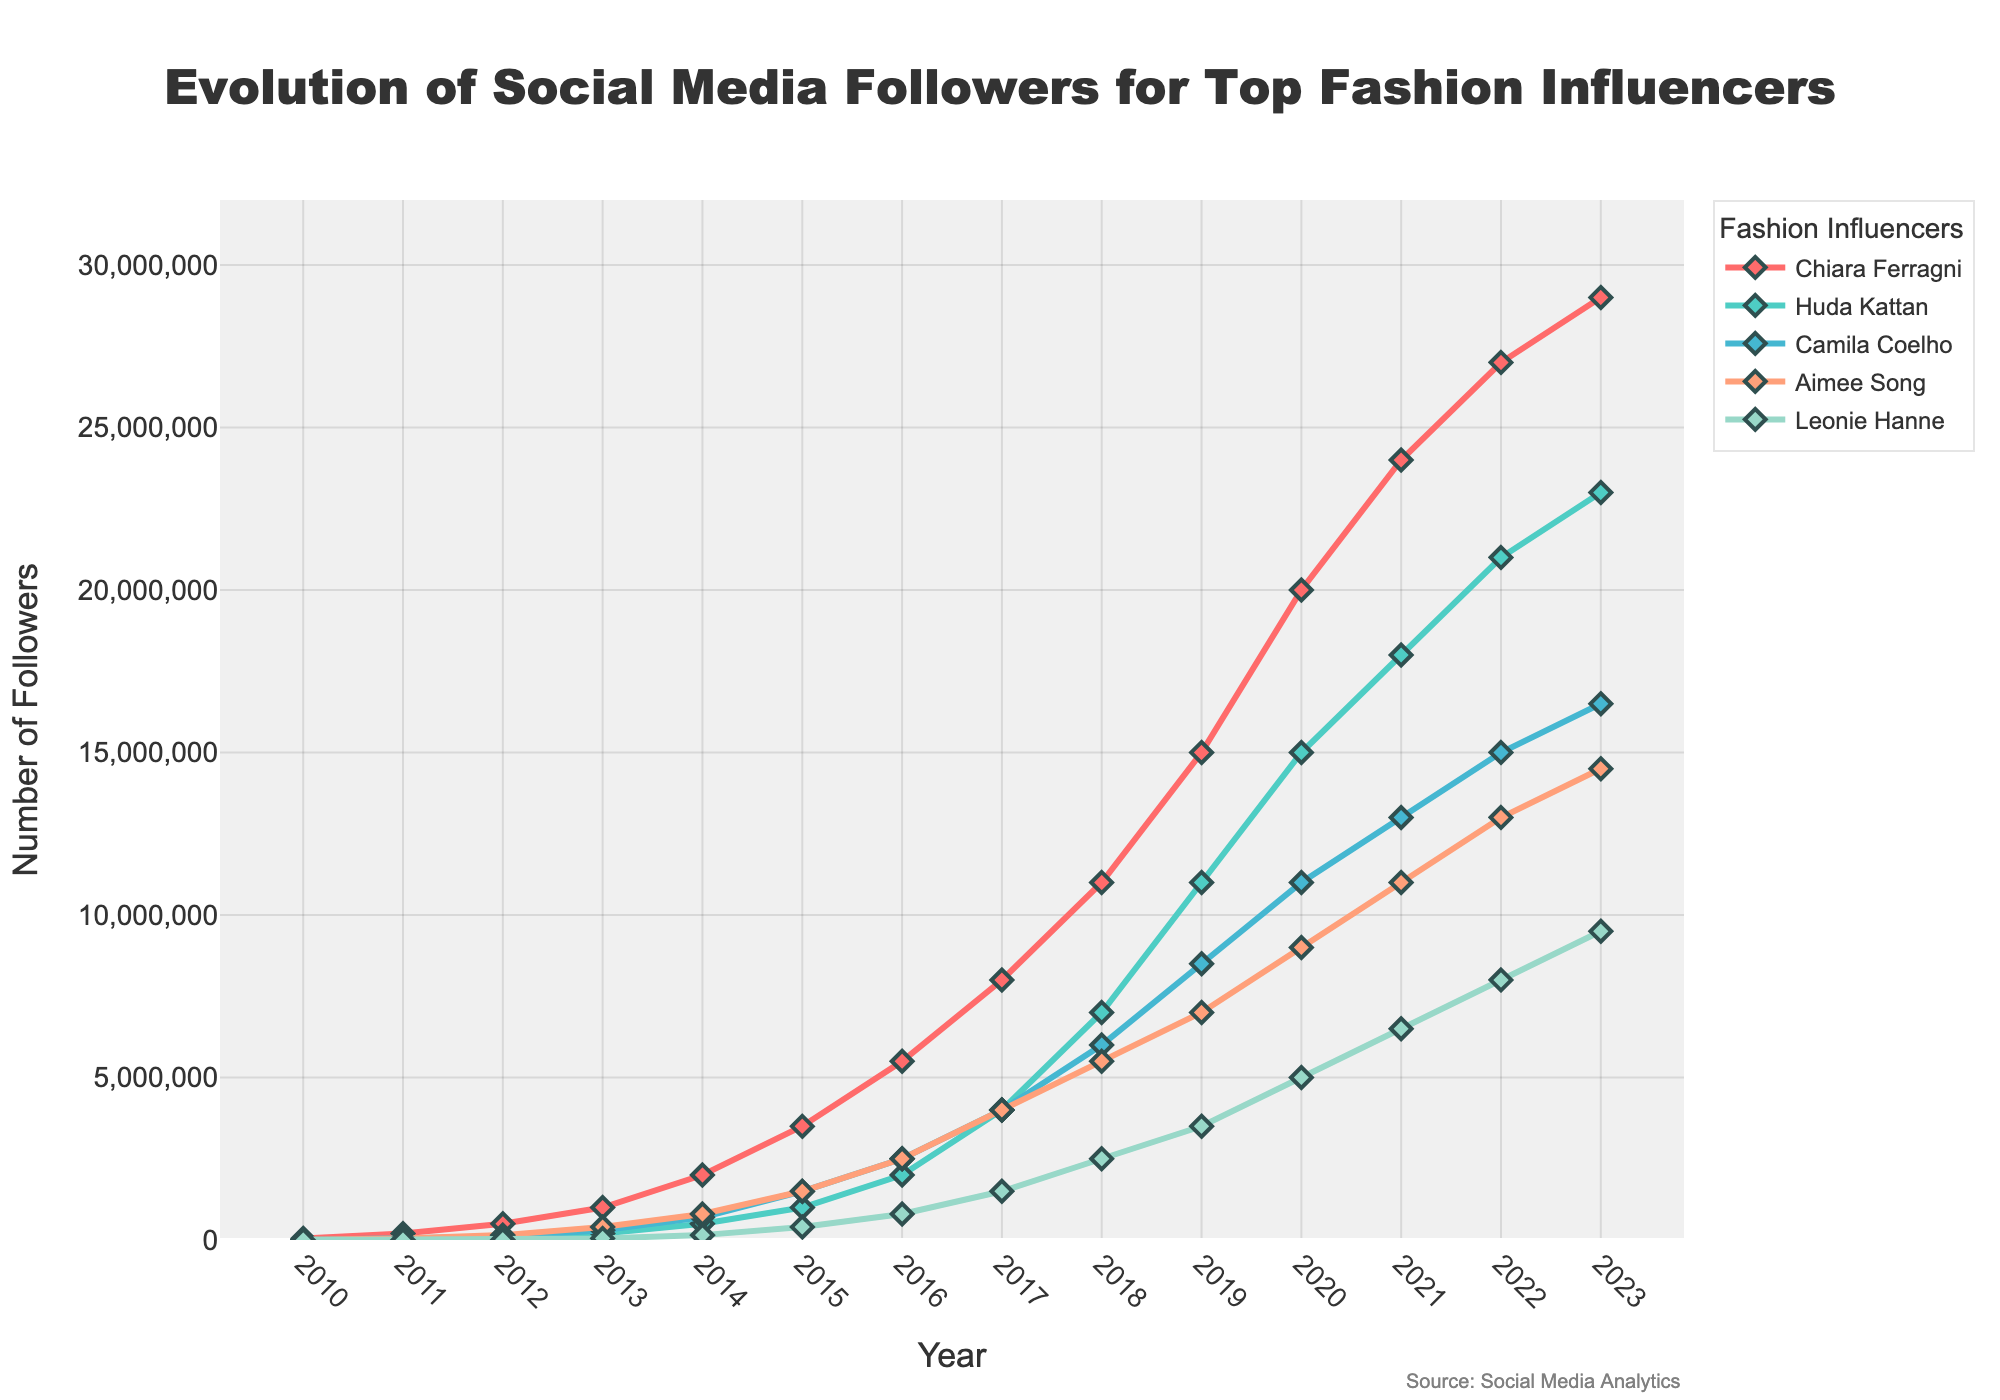Which influencer had the highest number of followers in 2023? By examining the line chart to identify the influencer with the highest value in 2023, Chiara Ferragni has the highest number of followers at around 29 million.
Answer: Chiara Ferragni Between which years did Huda Kattan's follower count grow the most significantly? Looking at the steepest slope in Huda Kattan's line, the follower count grew most significantly between 2018 and 2019.
Answer: 2018-2019 Which two influencers had approximately equal number of followers in 2017? By comparing the lines in 2017, Camila Coelho and Aimee Song both had approximately 4 million followers.
Answer: Camila Coelho and Aimee Song Which influencer shows a slower rate of growth from 2010 to 2023 compared to others? Checking the slope of the lines, Leonie Hanne has a slower rate of growth in followers compared to others.
Answer: Leonie Hanne What is the total number of followers for Aimee Song and Leonie Hanne combined in 2023? Adding the follower counts for Aimee Song (14.5 million) and Leonie Hanne (9.5 million) in 2023, we get a total of 24 million followers.
Answer: 24 million How many years did it take for Chiara Ferragni to reach 10 million followers from 2010? From the line chart, Chiara Ferragni reached 10 million followers in 2018, starting from 50,000 in 2010. So it took her 8 years to reach 10 million followers.
Answer: 8 years Who had more followers in 2015, Aimee Song or Camila Coelho, and by how many? Observing the chart, Camila Coelho had 1.5 million followers, while Aimee Song also had 1.5 million. They had the same number of followers that year.
Answer: Same Which year did all influencers have above 1 million followers? By examining the chart, all influencers had above 1 million followers by 2017.
Answer: 2017 What's the sum of followers for all influencers in 2020? Adding each influencer's followers in 2020: Chiara Ferragni (20M) + Huda Kattan (15M) + Camila Coelho (11M) + Aimee Song (9M) + Leonie Hanne (5M) = 60 million.
Answer: 60 million 